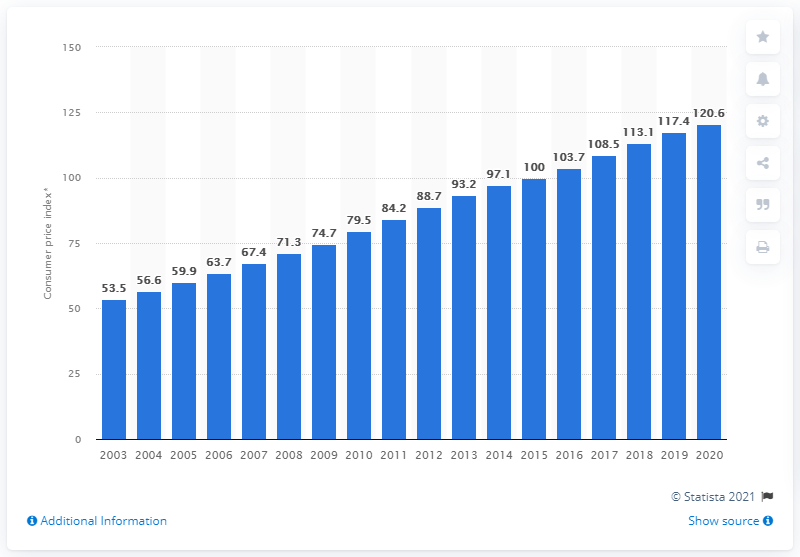Give some essential details in this illustration. The annual average price index value of hospital services in 2020 was 120.6. 